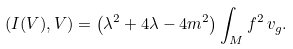<formula> <loc_0><loc_0><loc_500><loc_500>( I ( V ) , V ) = \left ( \lambda ^ { 2 } + 4 \lambda - 4 m ^ { 2 } \right ) \int _ { M } f ^ { 2 } \, v _ { g } .</formula> 